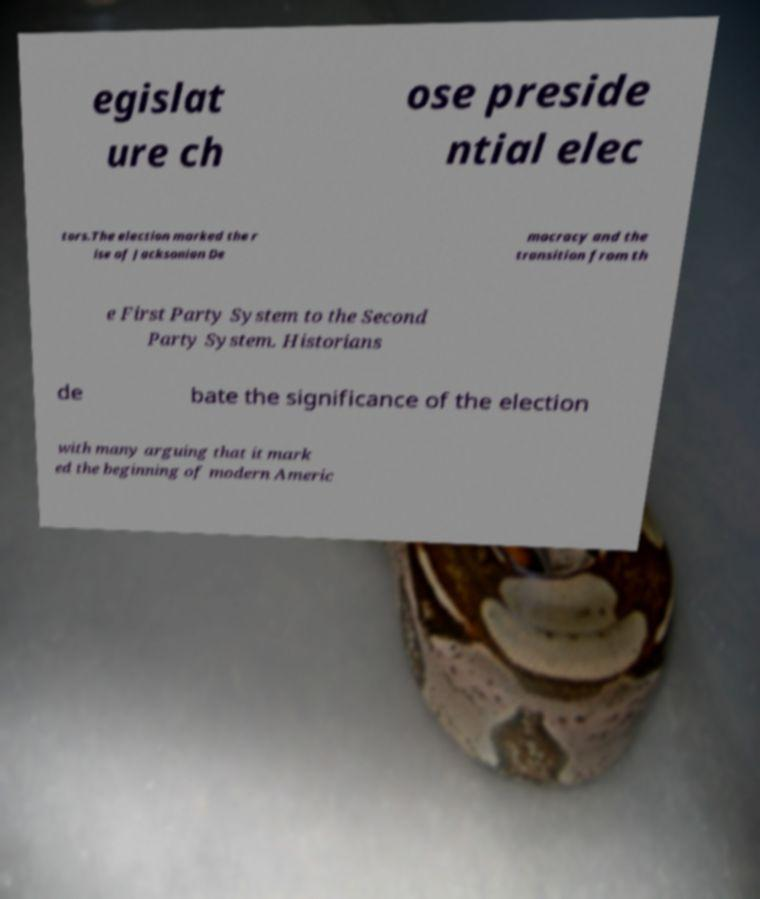Could you assist in decoding the text presented in this image and type it out clearly? egislat ure ch ose preside ntial elec tors.The election marked the r ise of Jacksonian De mocracy and the transition from th e First Party System to the Second Party System. Historians de bate the significance of the election with many arguing that it mark ed the beginning of modern Americ 